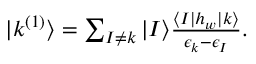Convert formula to latex. <formula><loc_0><loc_0><loc_500><loc_500>\begin{array} { r } { | k ^ { ( 1 ) } \rangle = \sum _ { I \ne k } | I \rangle \frac { \langle I | h _ { w } | k \rangle } { \epsilon _ { k } - \epsilon _ { I } } . } \end{array}</formula> 